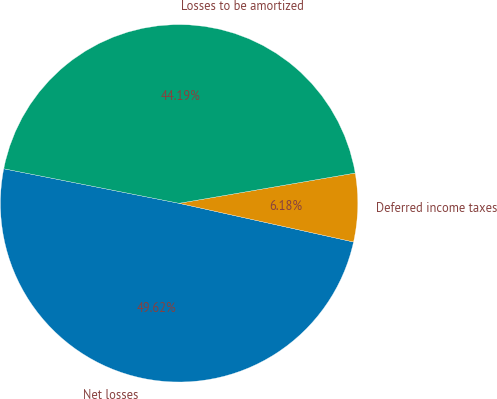<chart> <loc_0><loc_0><loc_500><loc_500><pie_chart><fcel>Net losses<fcel>Deferred income taxes<fcel>Losses to be amortized<nl><fcel>49.62%<fcel>6.18%<fcel>44.19%<nl></chart> 